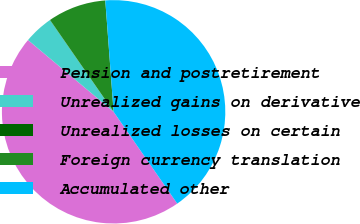Convert chart to OTSL. <chart><loc_0><loc_0><loc_500><loc_500><pie_chart><fcel>Pension and postretirement<fcel>Unrealized gains on derivative<fcel>Unrealized losses on certain<fcel>Foreign currency translation<fcel>Accumulated other<nl><fcel>45.75%<fcel>4.24%<fcel>0.02%<fcel>8.45%<fcel>41.54%<nl></chart> 